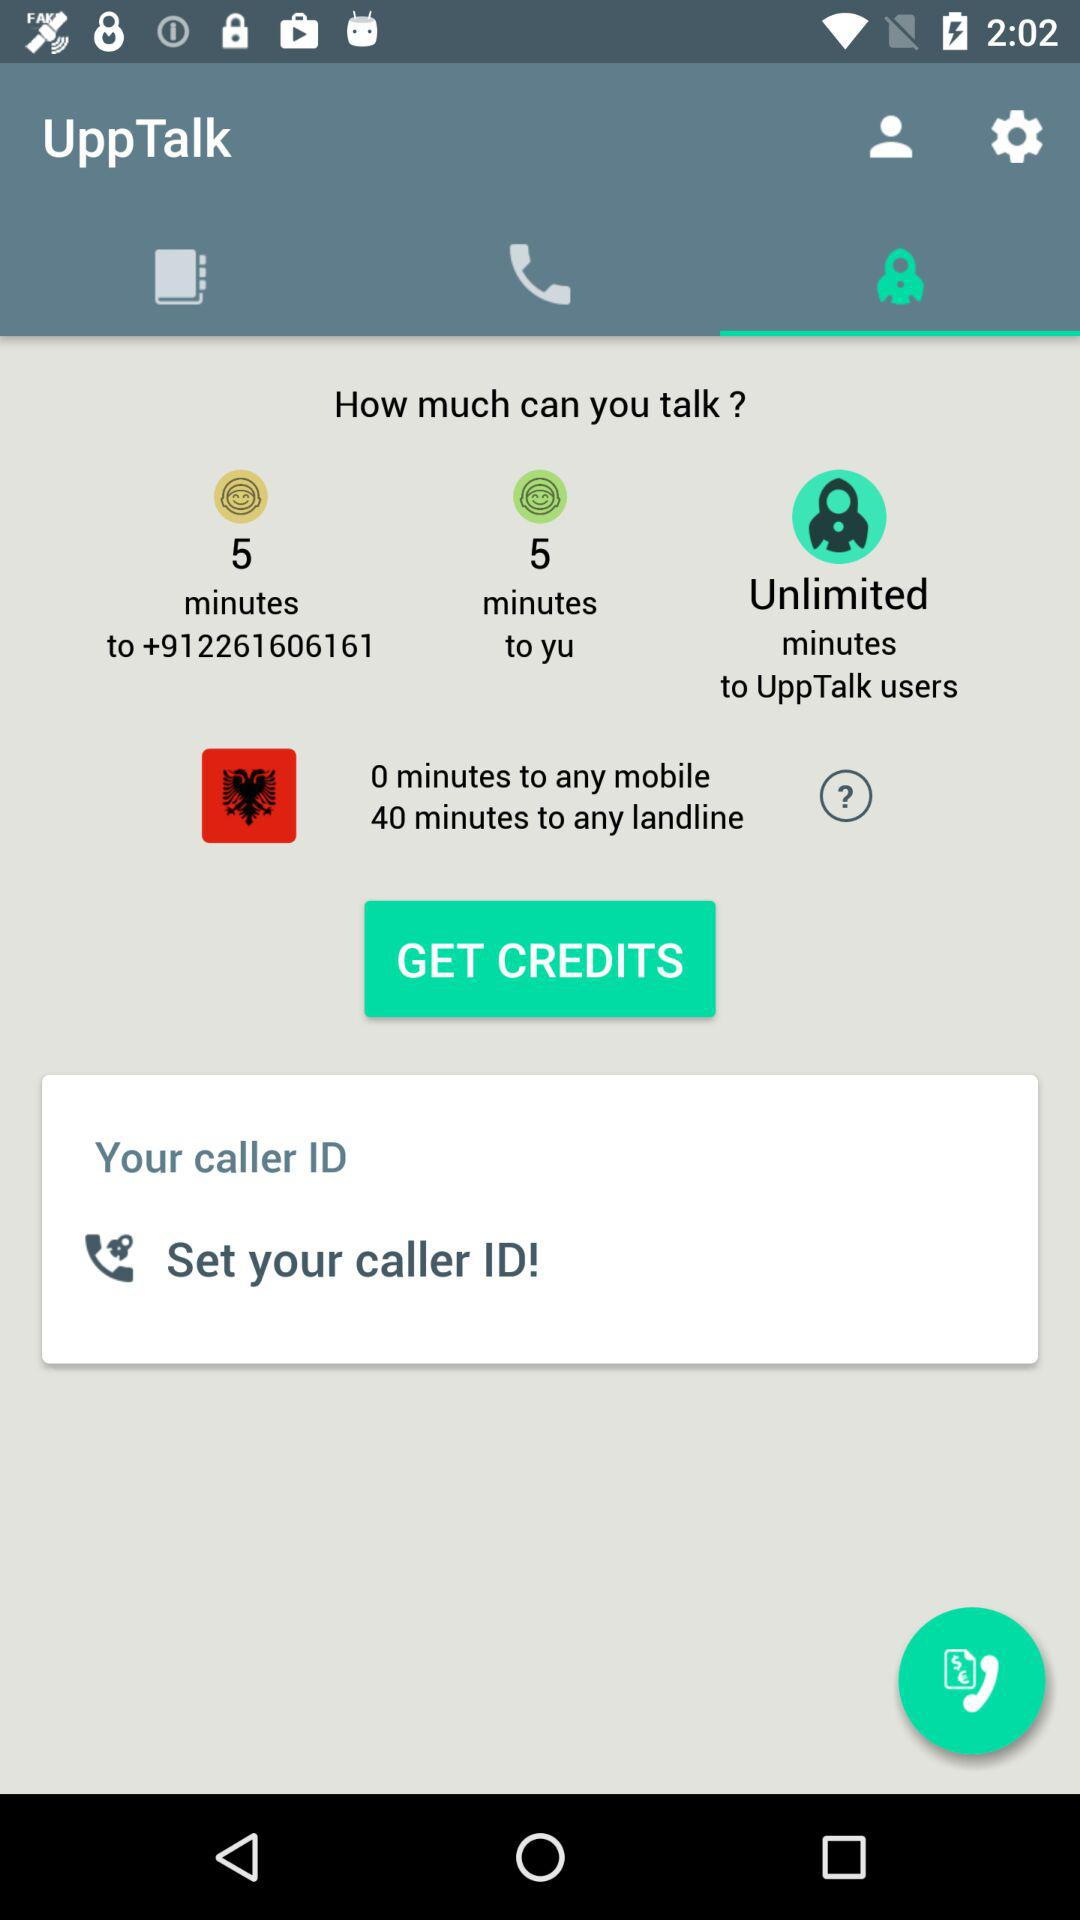How many minutes do you get to call UppTalk users?
Answer the question using a single word or phrase. Unlimited 